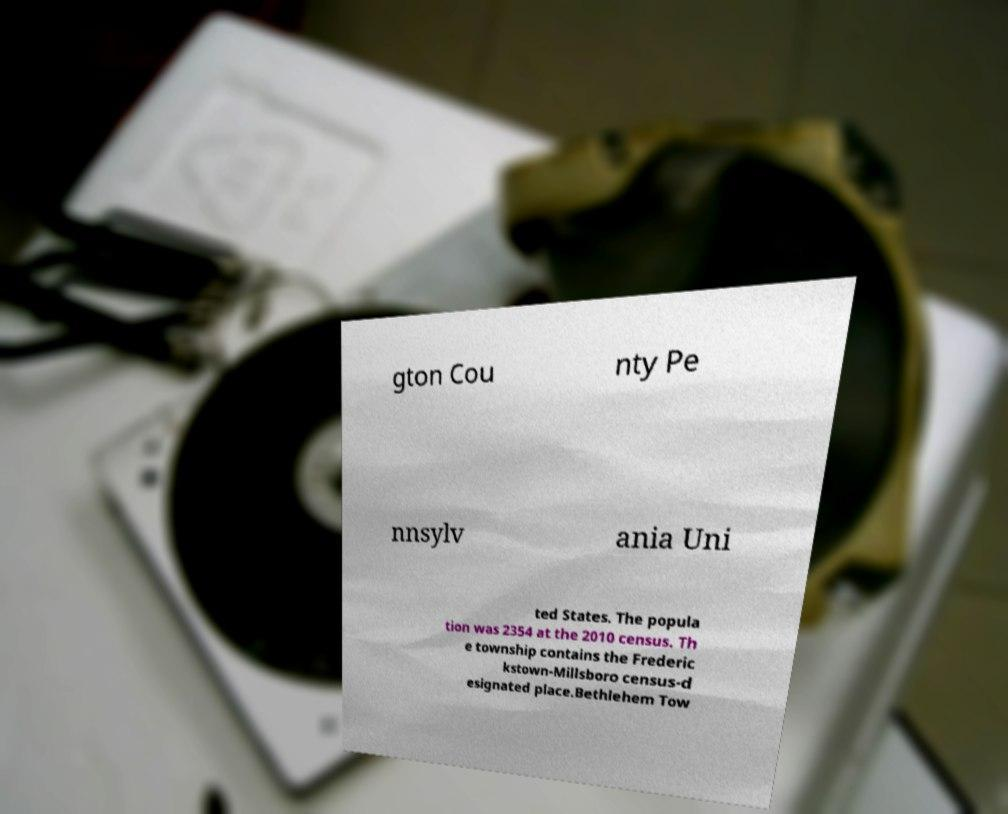For documentation purposes, I need the text within this image transcribed. Could you provide that? gton Cou nty Pe nnsylv ania Uni ted States. The popula tion was 2354 at the 2010 census. Th e township contains the Frederic kstown-Millsboro census-d esignated place.Bethlehem Tow 